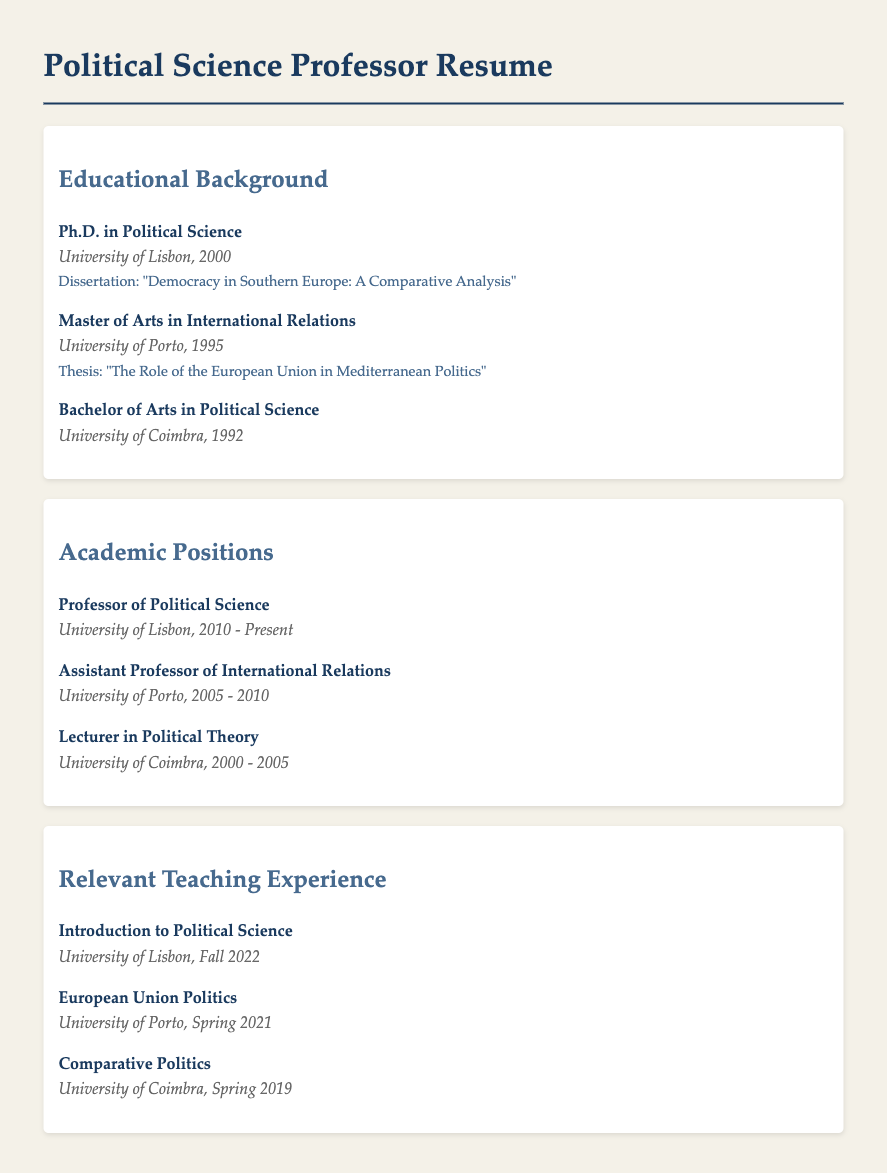What is the highest degree obtained? The highest degree listed is a Ph.D. in Political Science.
Answer: Ph.D. in Political Science What university awarded the Master of Arts? The Master of Arts in International Relations was awarded by the University of Porto.
Answer: University of Porto In what year did the individual complete their Bachelor's degree? The Bachelor's degree was completed in 1992.
Answer: 1992 Which position was held from 2005 to 2010? The position held during that period was Assistant Professor of International Relations.
Answer: Assistant Professor of International Relations What is the title of the dissertation? The title of the dissertation is "Democracy in Southern Europe: A Comparative Analysis".
Answer: "Democracy in Southern Europe: A Comparative Analysis" How many years has the professor been at the University of Lisbon as of now? The professor has been at the University of Lisbon since 2010, which totals 13 years as of 2023.
Answer: 13 years What course was taught in Spring 2019? The course taught in Spring 2019 was Comparative Politics.
Answer: Comparative Politics What is the focus of the thesis completed for the Master of Arts? The thesis focuses on "The Role of the European Union in Mediterranean Politics".
Answer: The Role of the European Union in Mediterranean Politics Where did the individual lecture in Political Theory? The individual lectured in Political Theory at the University of Coimbra.
Answer: University of Coimbra What course was taught in Fall 2022? The course taught in Fall 2022 was Introduction to Political Science.
Answer: Introduction to Political Science 